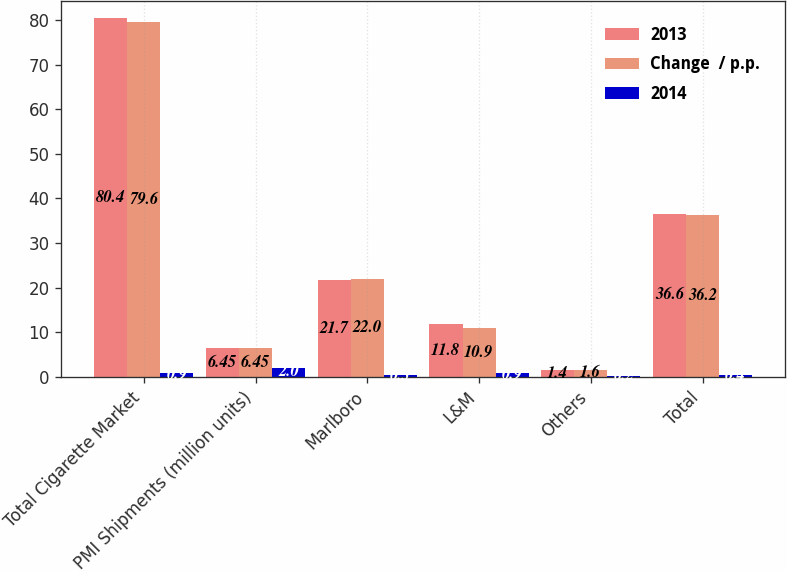Convert chart to OTSL. <chart><loc_0><loc_0><loc_500><loc_500><stacked_bar_chart><ecel><fcel>Total Cigarette Market<fcel>PMI Shipments (million units)<fcel>Marlboro<fcel>L&M<fcel>Others<fcel>Total<nl><fcel>2013<fcel>80.4<fcel>6.45<fcel>21.7<fcel>11.8<fcel>1.4<fcel>36.6<nl><fcel>Change  / p.p.<fcel>79.6<fcel>6.45<fcel>22<fcel>10.9<fcel>1.6<fcel>36.2<nl><fcel>2014<fcel>0.9<fcel>2<fcel>0.3<fcel>0.9<fcel>0.2<fcel>0.4<nl></chart> 